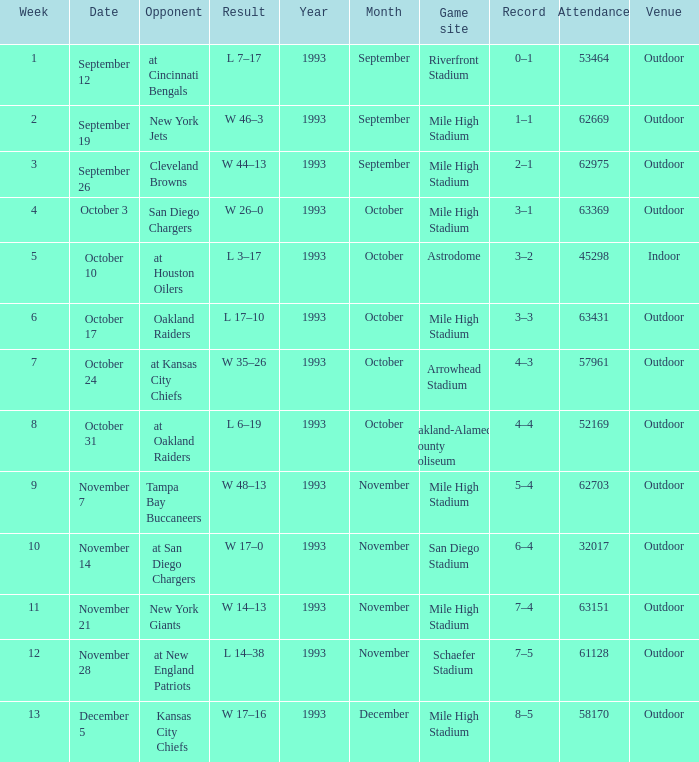What was the date of the week 4 game? October 3. 